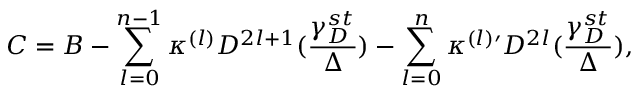Convert formula to latex. <formula><loc_0><loc_0><loc_500><loc_500>C = B - \sum _ { l = 0 } ^ { n - 1 } \kappa ^ { ( l ) } D ^ { 2 l + 1 } ( \frac { \gamma _ { D } ^ { s t } } { \Delta } ) - \sum _ { l = 0 } ^ { n } \kappa ^ { ( l ) \prime } D ^ { 2 l } ( \frac { \gamma _ { D } ^ { s t } } { \Delta } ) ,</formula> 